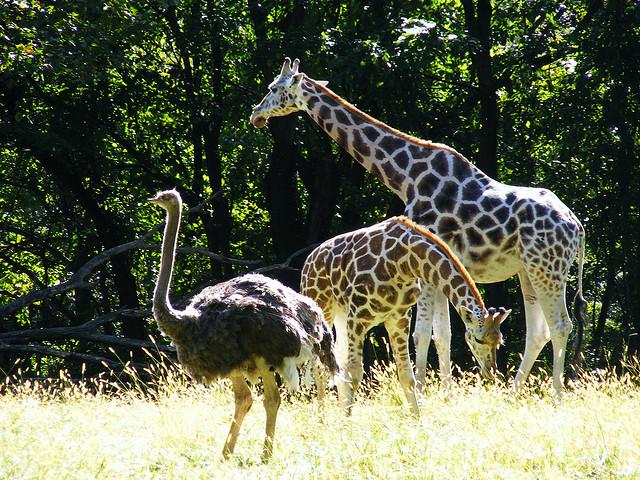Are these animals normally found together in the wild?
Quick response, please. No. What kind of bird is this?
Answer briefly. Ostrich. Which continent are these animals found in?
Quick response, please. Africa. 